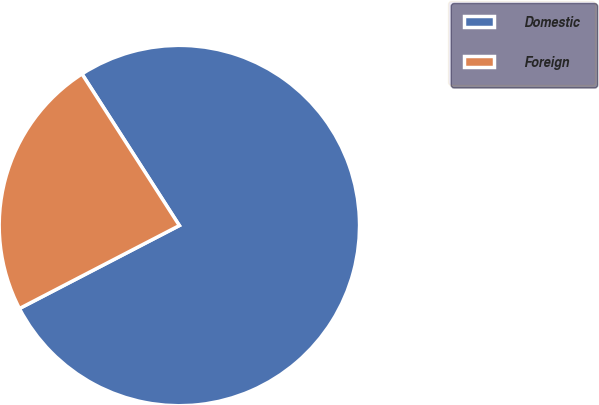Convert chart to OTSL. <chart><loc_0><loc_0><loc_500><loc_500><pie_chart><fcel>Domestic<fcel>Foreign<nl><fcel>76.47%<fcel>23.53%<nl></chart> 